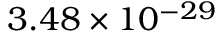Convert formula to latex. <formula><loc_0><loc_0><loc_500><loc_500>3 . 4 8 \times 1 0 ^ { - 2 9 }</formula> 